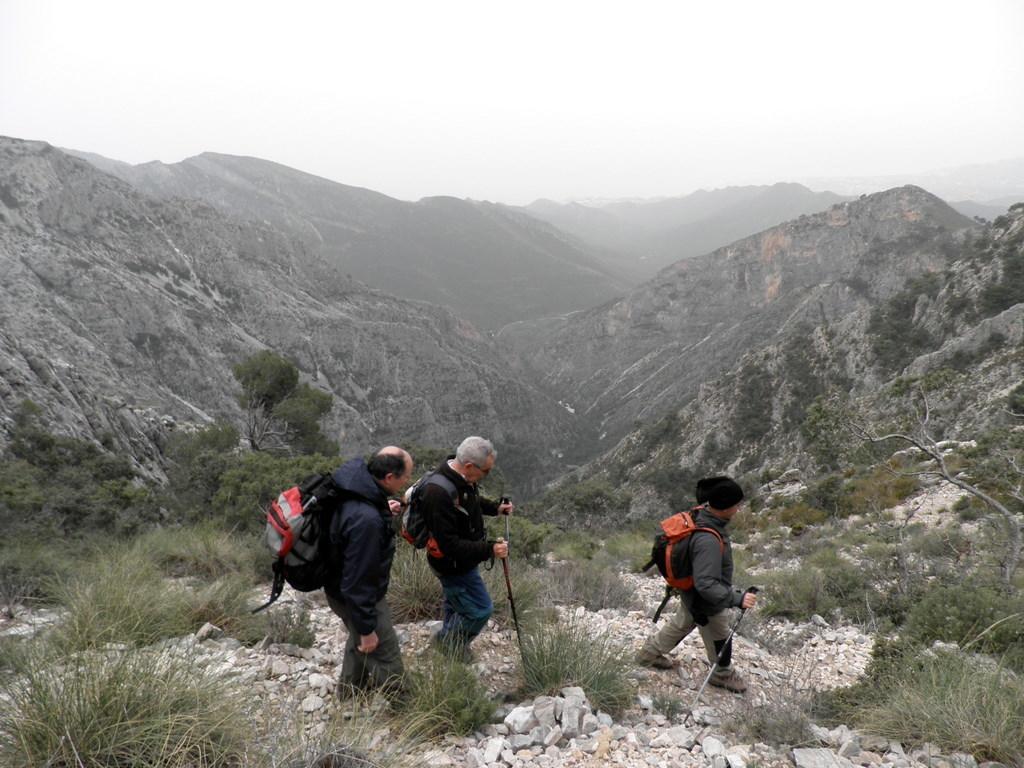Please provide a concise description of this image. These persons wore bags and facing towards the right side of the image. Here we can see plants. Background there are mountains.  